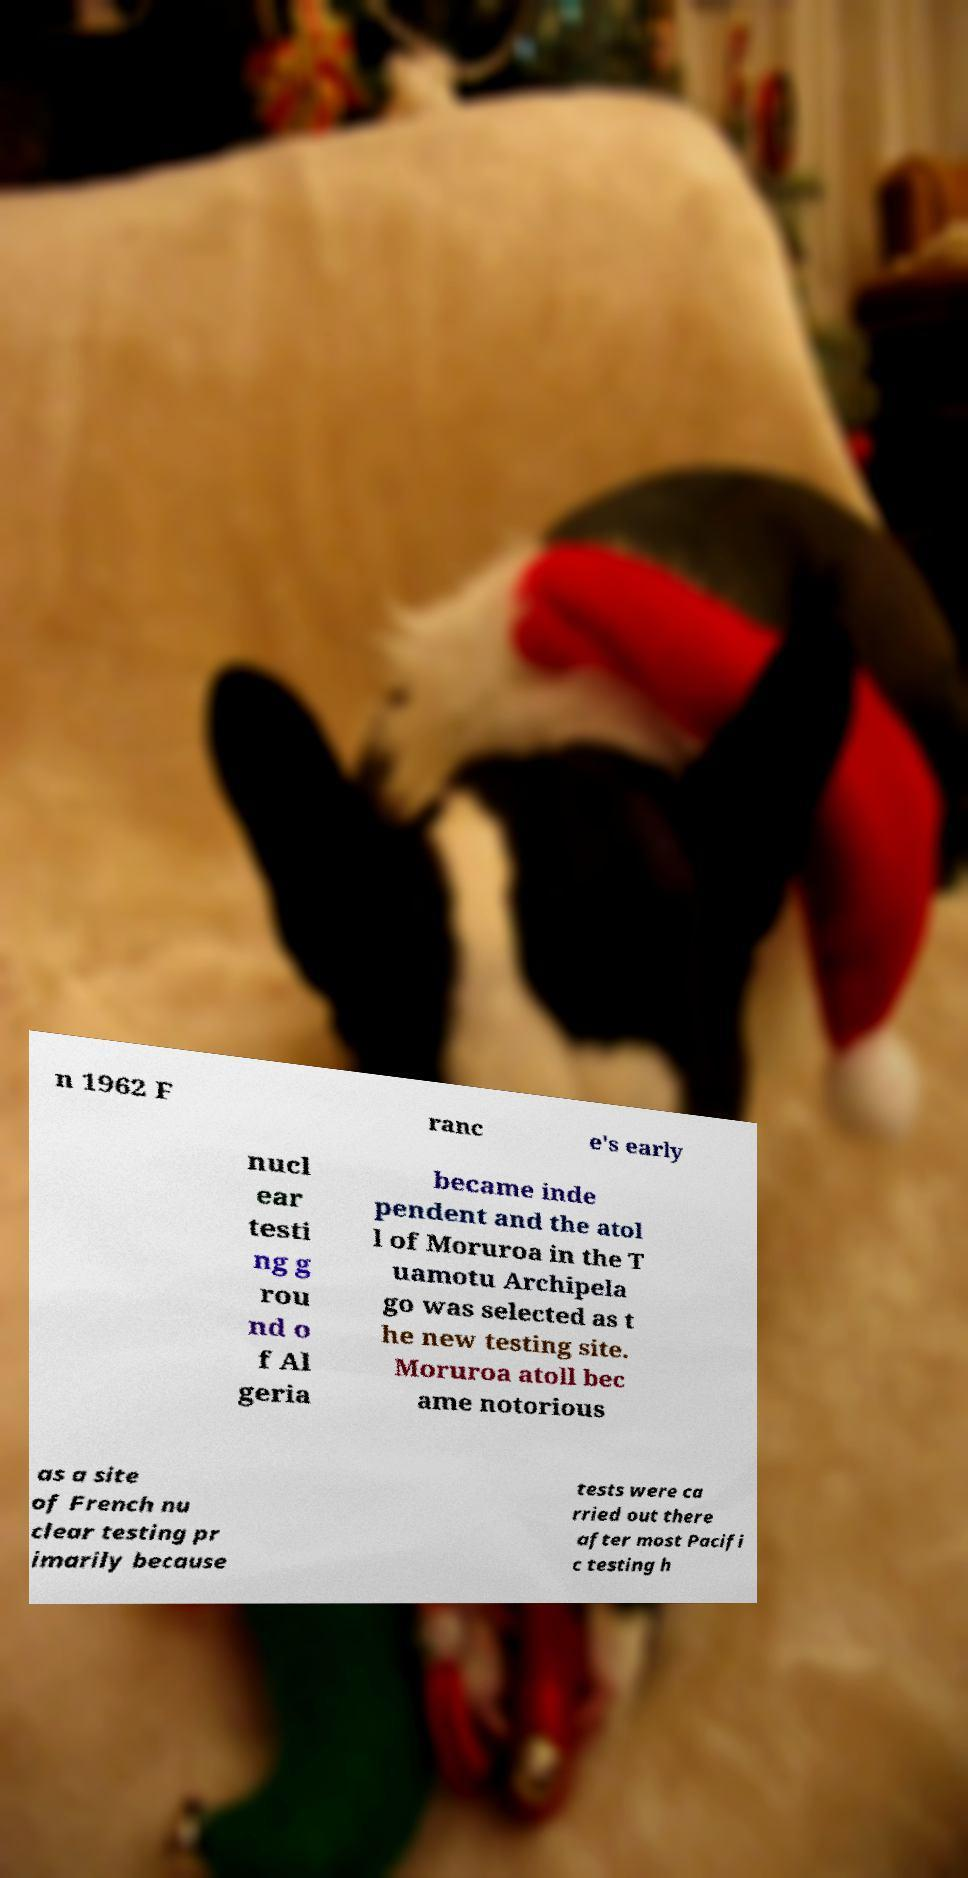Please read and relay the text visible in this image. What does it say? n 1962 F ranc e's early nucl ear testi ng g rou nd o f Al geria became inde pendent and the atol l of Moruroa in the T uamotu Archipela go was selected as t he new testing site. Moruroa atoll bec ame notorious as a site of French nu clear testing pr imarily because tests were ca rried out there after most Pacifi c testing h 